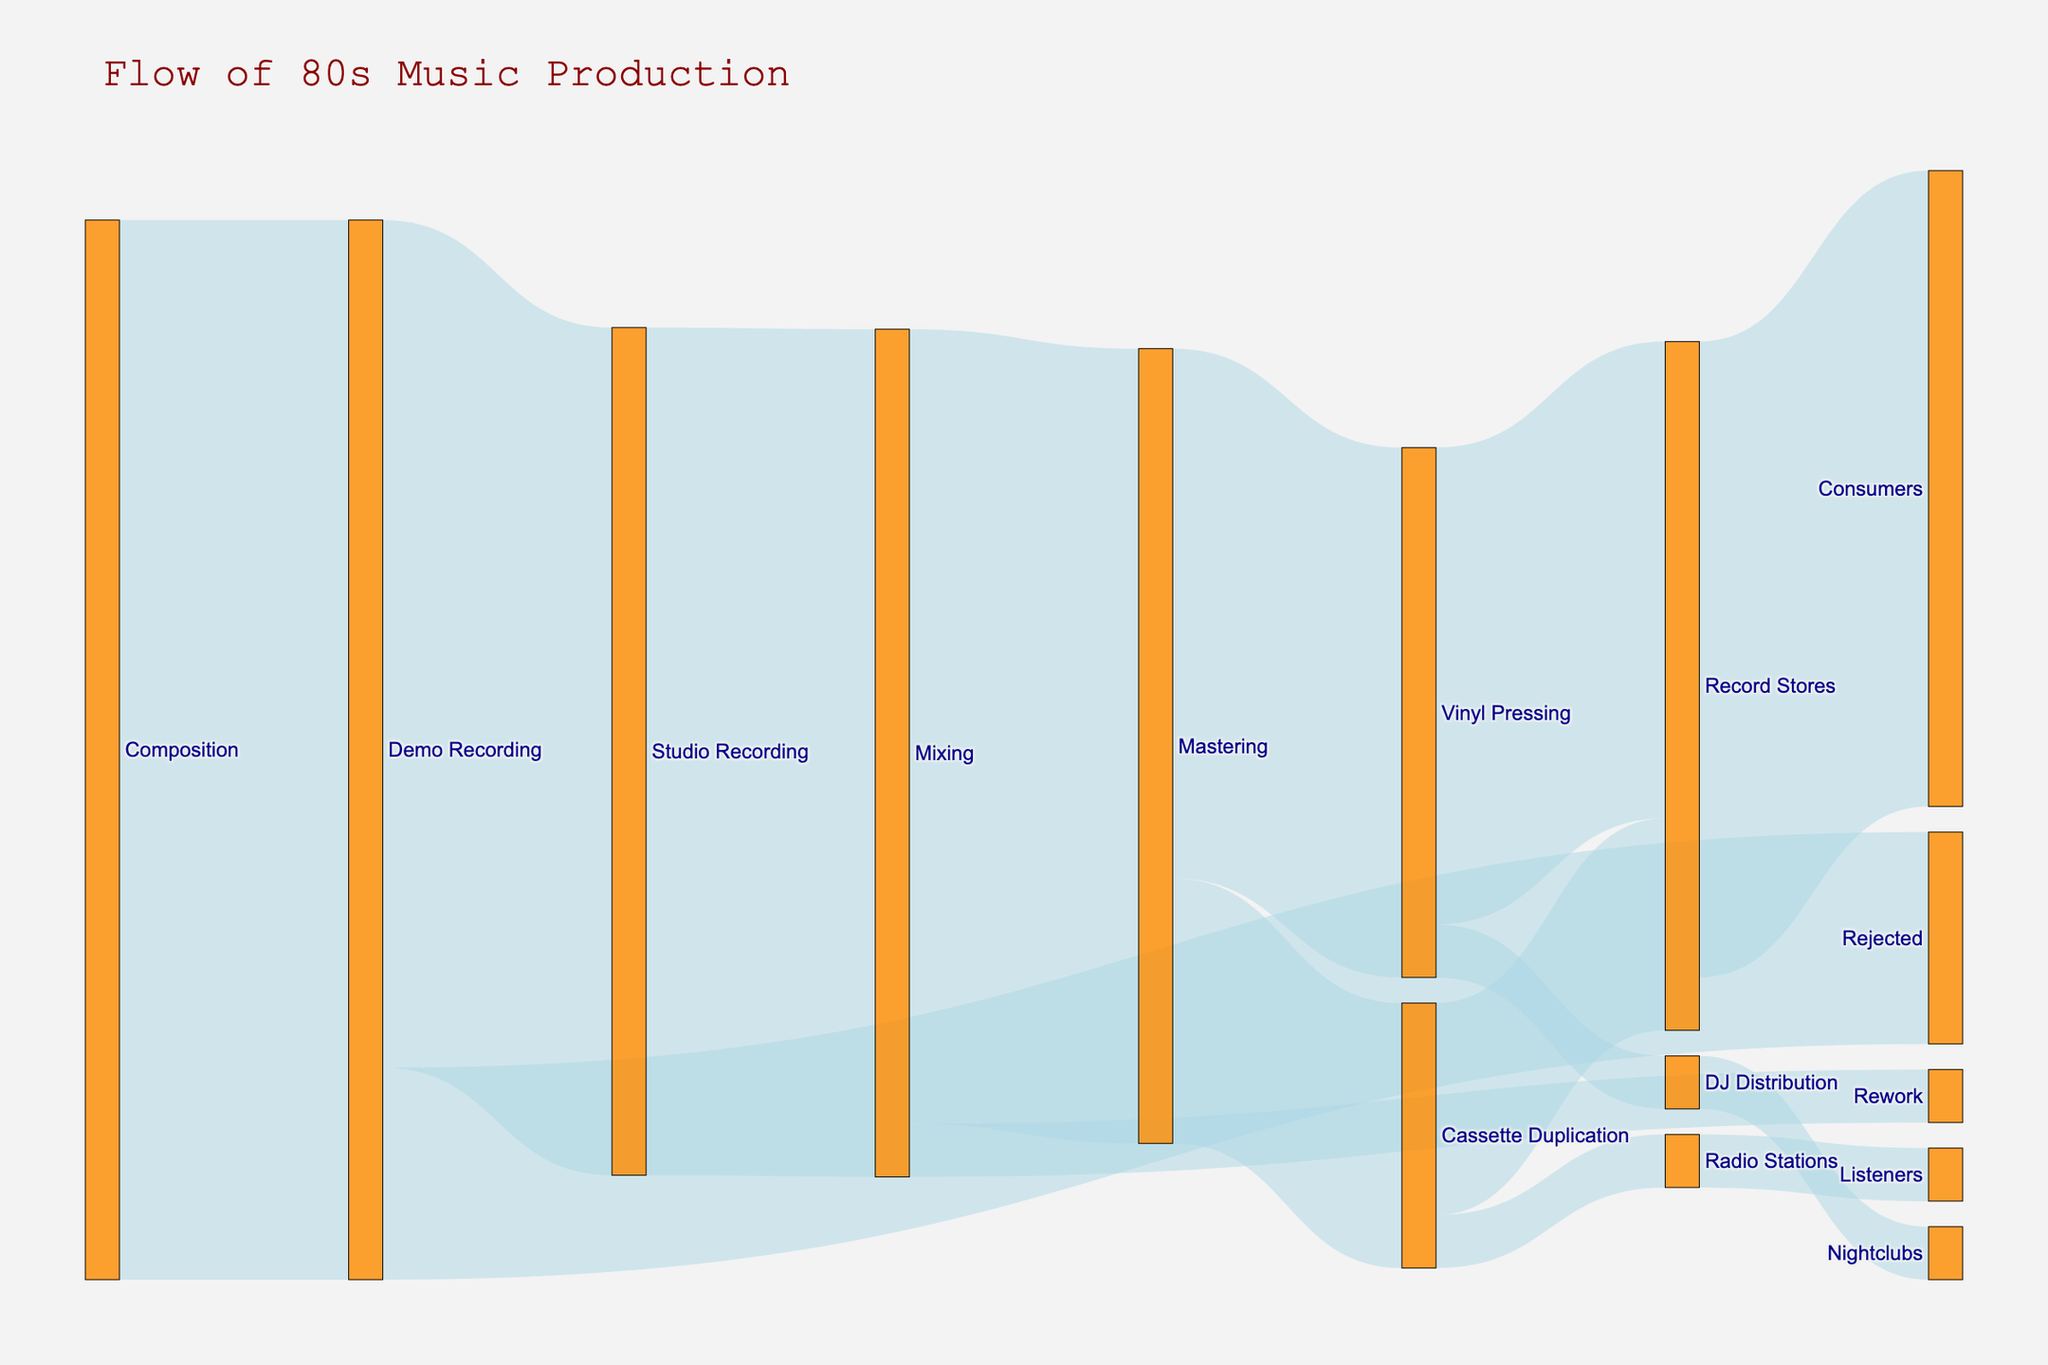What is the title of the Sankey diagram? The title is usually displayed prominently at the top of the diagram. It provides an overview of what the diagram represents.
Answer: "Flow of 80s Music Production" How many processes lead directly from 'Demo Recording'? By observing the 'source' node for 'Demo Recording', count the number of links emanating from it.
Answer: Two What is the flow value from 'Mastering' to 'Vinyl Pressing'? Check the link connecting 'Mastering' to 'Vinyl Pressing' and read the value shown.
Answer: 50 Which process receives the highest inflow value from 'Record Stores'? Look at the links targeting 'Record Stores' and compare their values.
Answer: Consumers What is the total outflow from 'Mastering'? Sum the values of all the links that originate from 'Mastering'. 50 (to Vinyl Pressing) + 25 (to Cassette Duplication) = 75
Answer: 75 How many processes lead to 'Record Stores'? Identify the number of links where 'Record Stores' is the target node.
Answer: Two Which process has the smallest flow value, and what is its value? Compare the values of all the links. The smallest value can be easily identified by finding the smallest number.
Answer: Mixing to Rework, 5 What happens to the 5 units that go from 'DJ Distribution'? Follow the link from 'DJ Distribution' to see where it leads.
Answer: Nightclubs Compare the flow values from 'Vinyl Pressing' to 'Record Stores' and 'Cassette Duplication' to 'Record Stores'. Which is higher? Examine the values of the links originating from 'Vinyl Pressing' to 'Record Stores' and 'Cassette Duplication' to 'Record Stores'. Compare the two values.
Answer: Vinyl Pressing to Record Stores What is the combined flow value from 'Vinyl Pressing' and 'Cassette Duplication' to 'Record Stores'? Add the values of the links from 'Vinyl Pressing' to 'Record Stores' and 'Cassette Duplication' to 'Record Stores'. 45 (from Vinyl Pressing) + 20 (from Cassette Duplication) = 65
Answer: 65 